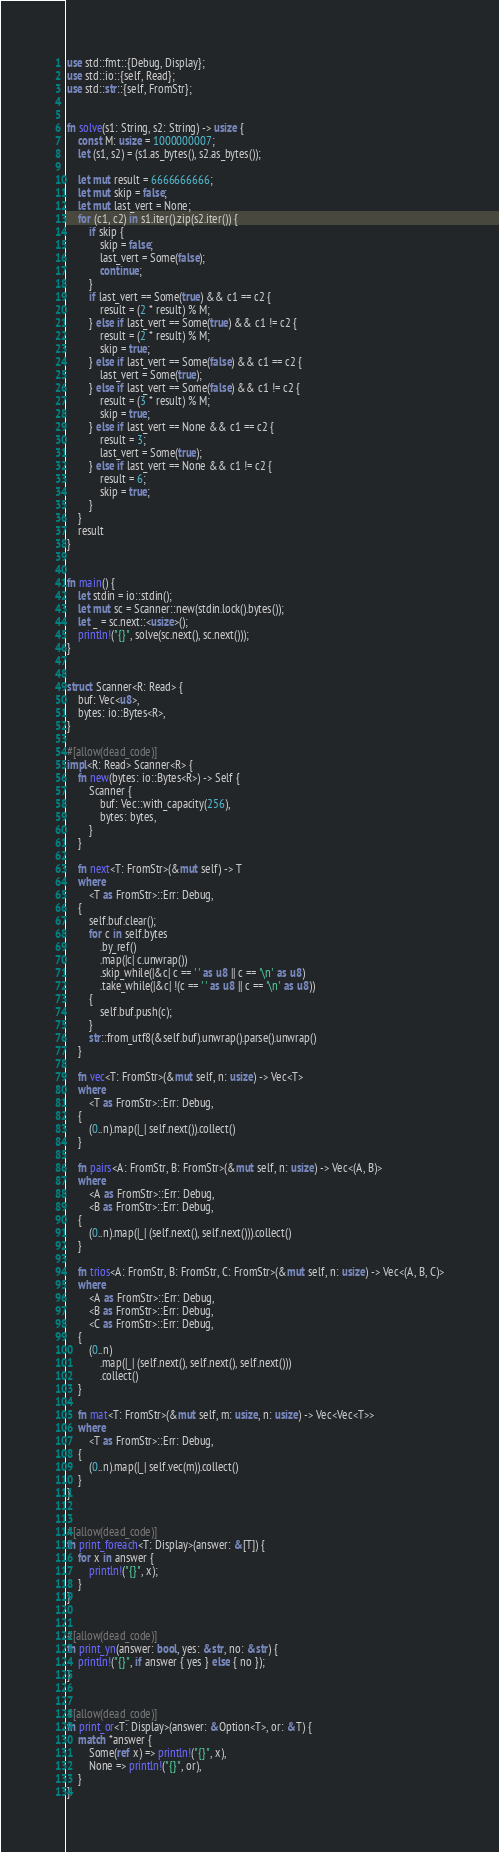<code> <loc_0><loc_0><loc_500><loc_500><_Rust_>use std::fmt::{Debug, Display};
use std::io::{self, Read};
use std::str::{self, FromStr};


fn solve(s1: String, s2: String) -> usize {
    const M: usize = 1000000007;
    let (s1, s2) = (s1.as_bytes(), s2.as_bytes());

    let mut result = 6666666666;
    let mut skip = false;
    let mut last_vert = None;
    for (c1, c2) in s1.iter().zip(s2.iter()) {
        if skip {
            skip = false;
            last_vert = Some(false);
            continue;
        }
        if last_vert == Some(true) && c1 == c2 {
            result = (2 * result) % M;
        } else if last_vert == Some(true) && c1 != c2 {
            result = (2 * result) % M;
            skip = true;
        } else if last_vert == Some(false) && c1 == c2 {
            last_vert = Some(true);
        } else if last_vert == Some(false) && c1 != c2 {
            result = (3 * result) % M;
            skip = true;
        } else if last_vert == None && c1 == c2 {
            result = 3;
            last_vert = Some(true);
        } else if last_vert == None && c1 != c2 {
            result = 6;
            skip = true;
        }
    }
    result
}


fn main() {
    let stdin = io::stdin();
    let mut sc = Scanner::new(stdin.lock().bytes());
    let _ = sc.next::<usize>();
    println!("{}", solve(sc.next(), sc.next()));
}


struct Scanner<R: Read> {
    buf: Vec<u8>,
    bytes: io::Bytes<R>,
}

#[allow(dead_code)]
impl<R: Read> Scanner<R> {
    fn new(bytes: io::Bytes<R>) -> Self {
        Scanner {
            buf: Vec::with_capacity(256),
            bytes: bytes,
        }
    }

    fn next<T: FromStr>(&mut self) -> T
    where
        <T as FromStr>::Err: Debug,
    {
        self.buf.clear();
        for c in self.bytes
            .by_ref()
            .map(|c| c.unwrap())
            .skip_while(|&c| c == ' ' as u8 || c == '\n' as u8)
            .take_while(|&c| !(c == ' ' as u8 || c == '\n' as u8))
        {
            self.buf.push(c);
        }
        str::from_utf8(&self.buf).unwrap().parse().unwrap()
    }

    fn vec<T: FromStr>(&mut self, n: usize) -> Vec<T>
    where
        <T as FromStr>::Err: Debug,
    {
        (0..n).map(|_| self.next()).collect()
    }

    fn pairs<A: FromStr, B: FromStr>(&mut self, n: usize) -> Vec<(A, B)>
    where
        <A as FromStr>::Err: Debug,
        <B as FromStr>::Err: Debug,
    {
        (0..n).map(|_| (self.next(), self.next())).collect()
    }

    fn trios<A: FromStr, B: FromStr, C: FromStr>(&mut self, n: usize) -> Vec<(A, B, C)>
    where
        <A as FromStr>::Err: Debug,
        <B as FromStr>::Err: Debug,
        <C as FromStr>::Err: Debug,
    {
        (0..n)
            .map(|_| (self.next(), self.next(), self.next()))
            .collect()
    }

    fn mat<T: FromStr>(&mut self, m: usize, n: usize) -> Vec<Vec<T>>
    where
        <T as FromStr>::Err: Debug,
    {
        (0..n).map(|_| self.vec(m)).collect()
    }
}


#[allow(dead_code)]
fn print_foreach<T: Display>(answer: &[T]) {
    for x in answer {
        println!("{}", x);
    }
}


#[allow(dead_code)]
fn print_yn(answer: bool, yes: &str, no: &str) {
    println!("{}", if answer { yes } else { no });
}


#[allow(dead_code)]
fn print_or<T: Display>(answer: &Option<T>, or: &T) {
    match *answer {
        Some(ref x) => println!("{}", x),
        None => println!("{}", or),
    }
}
</code> 